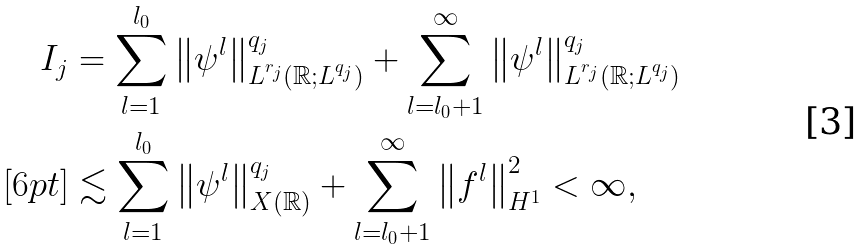<formula> <loc_0><loc_0><loc_500><loc_500>I _ { j } & = \sum _ { l = 1 } ^ { l _ { 0 } } \left \| \psi ^ { l } \right \| _ { L ^ { r _ { j } } ( \mathbb { R } ; L ^ { q _ { j } } ) } ^ { q _ { j } } + \sum _ { l = l _ { 0 } + 1 } ^ { \infty } \left \| \psi ^ { l } \right \| _ { L ^ { r _ { j } } ( \mathbb { R } ; L ^ { q _ { j } } ) } ^ { q _ { j } } \\ [ 6 p t ] & \lesssim \sum _ { l = 1 } ^ { l _ { 0 } } \left \| \psi ^ { l } \right \| _ { X ( \mathbb { R } ) } ^ { q _ { j } } + \sum _ { l = l _ { 0 } + 1 } ^ { \infty } \left \| f ^ { l } \right \| _ { H ^ { 1 } } ^ { 2 } < \infty ,</formula> 